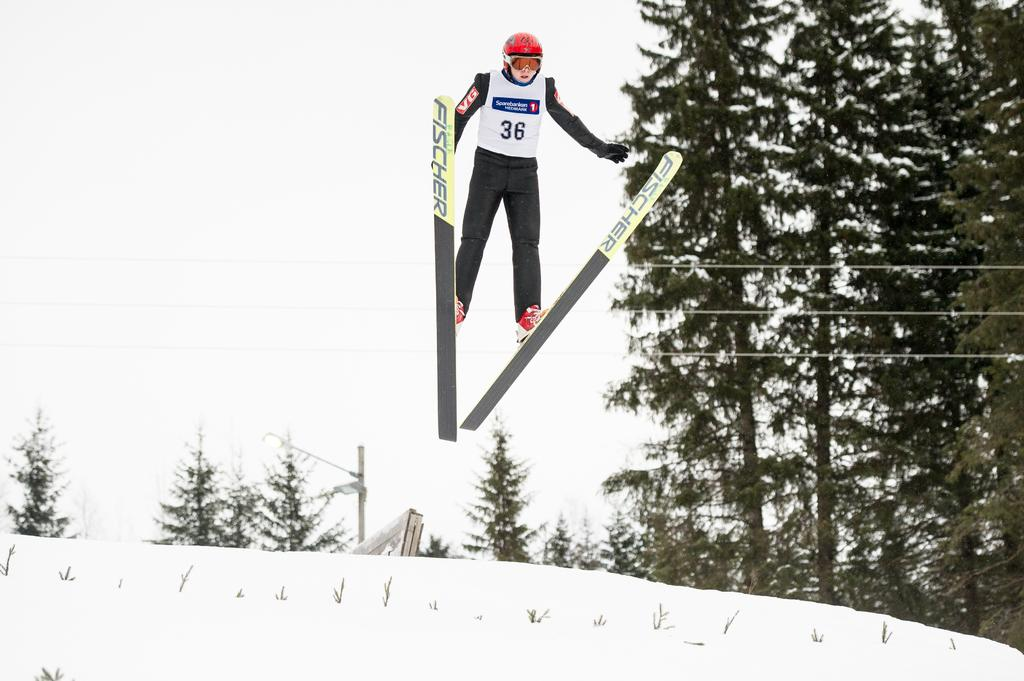How is the person in the image positioned? The person is in the air. What is the person wearing in the image? The person is wearing a white coat and black trousers. What is the ground made of in the image? There is snow at the bottom of the image. What type of vegetation can be seen in the image? There are trees in the image. What type of science experiment is being conducted in the image? There is no indication of a science experiment being conducted in the image. Is the person in the image fighting with someone else? There is no indication of a fight or any conflict in the image. 